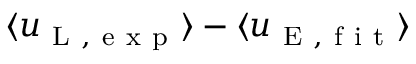<formula> <loc_0><loc_0><loc_500><loc_500>\langle u _ { L , e x p } \rangle - \langle u _ { E , f i t } \rangle</formula> 